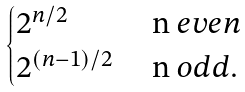Convert formula to latex. <formula><loc_0><loc_0><loc_500><loc_500>\begin{cases} 2 ^ { n / 2 } & $ n $ e v e n \\ 2 ^ { ( n - 1 ) / 2 } & $ n $ o d d . \end{cases}</formula> 